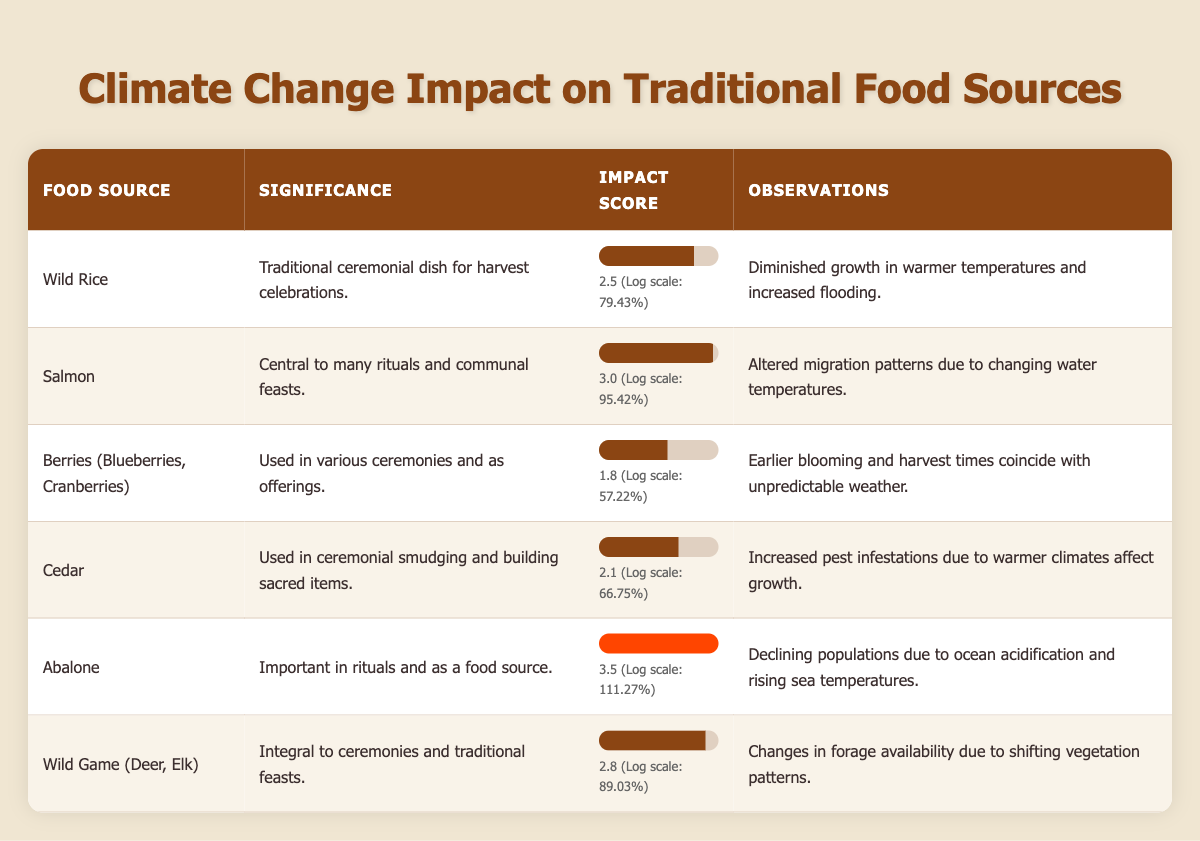What is the significance of wild rice in traditional ceremonies? The table states that wild rice is a traditional ceremonial dish used for harvest celebrations, reflecting its cultural importance to the community.
Answer: Traditional ceremonial dish for harvest celebrations Which food source has the highest impact score according to the table? By reviewing the impact scores, abalone has the highest score of 3.5, indicating it is most affected by climate change compared to the others listed.
Answer: Abalone Is it true that berries are used in ceremonies and have an impact score above 2.0? The table shows that berries (blueberries, cranberries) are indeed used in various ceremonies, but their impact score is 1.8, which is below 2.0. Thus, the statement is false.
Answer: False What is the difference in impact scores between salmon and wild game? For salmon, the impact score is 3.0, and for wild game, it is 2.8. Therefore, the difference is 3.0 - 2.8 = 0.2.
Answer: 0.2 What can be inferred about the impact of climate change on all the listed food sources? All listed food sources are significantly impacted by climate change, as evidenced by their impact scores ranging from 1.8 to 3.5, indicating varying degrees of threat to their availability and cultural significance.
Answer: All are significantly impacted What is the average impact score of the food sources listed in the table? The impact scores are 2.5, 3.0, 1.8, 2.1, 3.5, and 2.8. Adding these gives 15.7. There are 6 items, so the average is 15.7 / 6 = 2.6167, approximately 2.62.
Answer: Approximately 2.62 